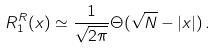<formula> <loc_0><loc_0><loc_500><loc_500>R _ { 1 } ^ { R } ( x ) \simeq \frac { 1 } { \sqrt { 2 \pi } } \Theta ( \sqrt { N } - | x | ) \, .</formula> 